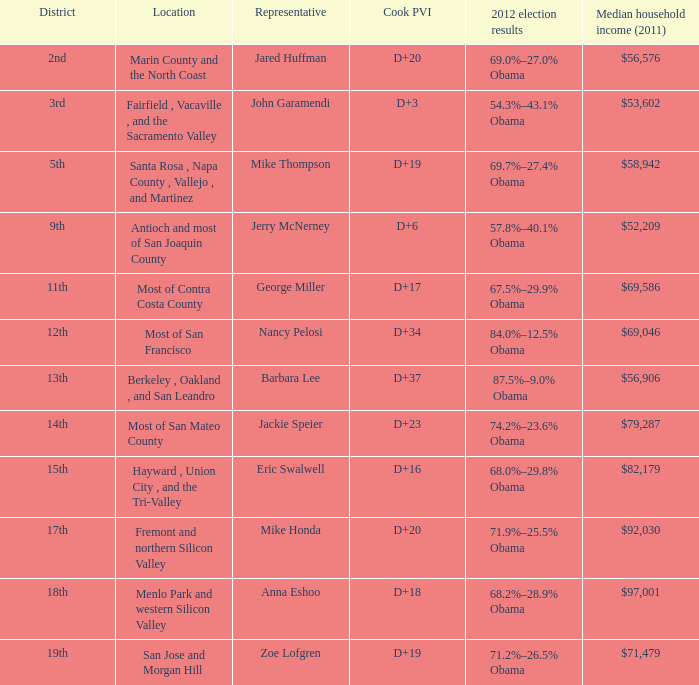How many locations have a median household income in 2011 of $71,479? 1.0. 